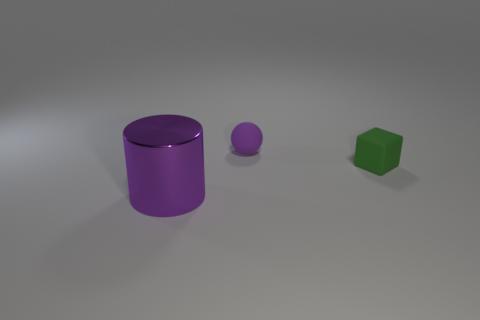What number of spheres are the same color as the block? There are zero spheres with the same color as the block. The block is green, while the spheres and the cylinder are varying shades of purple. 